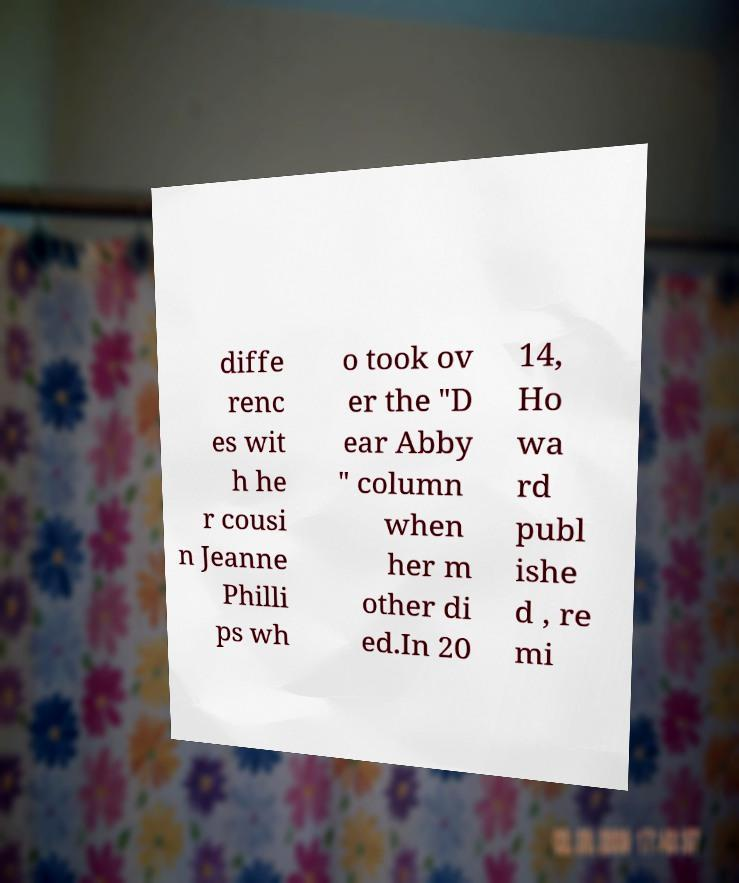Can you accurately transcribe the text from the provided image for me? diffe renc es wit h he r cousi n Jeanne Philli ps wh o took ov er the "D ear Abby " column when her m other di ed.In 20 14, Ho wa rd publ ishe d , re mi 